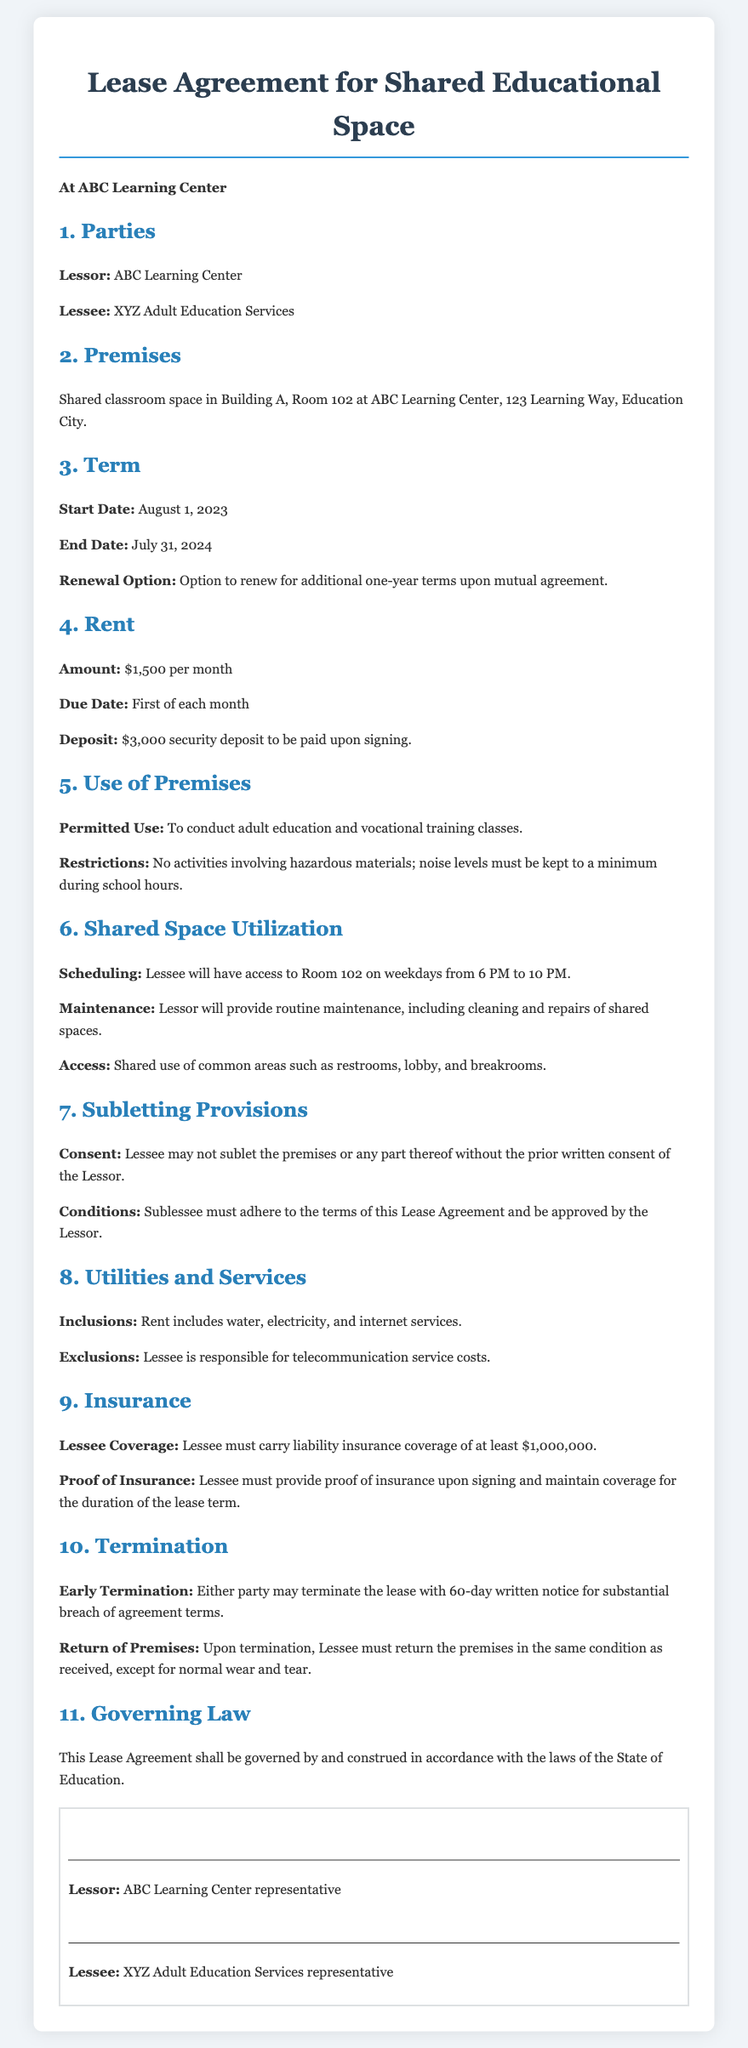What is the name of the Lessor? The Lessor is ABC Learning Center, as stated in the document.
Answer: ABC Learning Center What is the monthly rent amount? The monthly rent amount is specified in the document as $1,500.
Answer: $1,500 What is the security deposit? The document specifies that the security deposit to be paid upon signing is $3,000.
Answer: $3,000 What are the permitted hours of access for the Lessee? The document states that the Lessee will have access to Room 102 on weekdays from 6 PM to 10 PM.
Answer: 6 PM to 10 PM What must the Lessee have before subletting? The document requires that the Lessee must obtain prior written consent of the Lessor before subletting.
Answer: Prior written consent What is the duration of the lease term? The lease term starts on August 1, 2023, and ends on July 31, 2024, which indicates a 1-year duration.
Answer: 1 year What is included in the rent? The document notes that the rent includes water, electricity, and internet services.
Answer: Water, electricity, and internet services How much notice is required for early termination? The document specifies that either party may terminate the lease with a 60-day written notice.
Answer: 60-day written notice What coverage amount is required for the Lessee’s insurance? The document states that the Lessee must carry liability insurance coverage of at least $1,000,000.
Answer: $1,000,000 